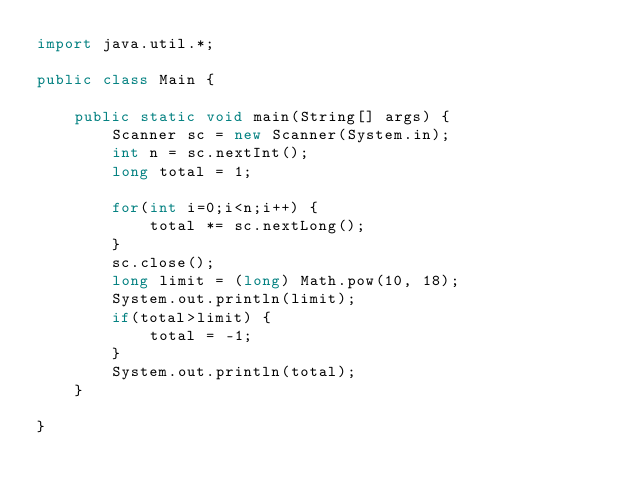Convert code to text. <code><loc_0><loc_0><loc_500><loc_500><_Java_>import java.util.*;

public class Main {

	public static void main(String[] args) {
		Scanner sc = new Scanner(System.in);
		int n = sc.nextInt();
		long total = 1;

		for(int i=0;i<n;i++) {
			total *= sc.nextLong();
		}
		sc.close();
		long limit = (long) Math.pow(10, 18);
		System.out.println(limit);
		if(total>limit) {
			total = -1;
		}
		System.out.println(total);
	}

}
</code> 